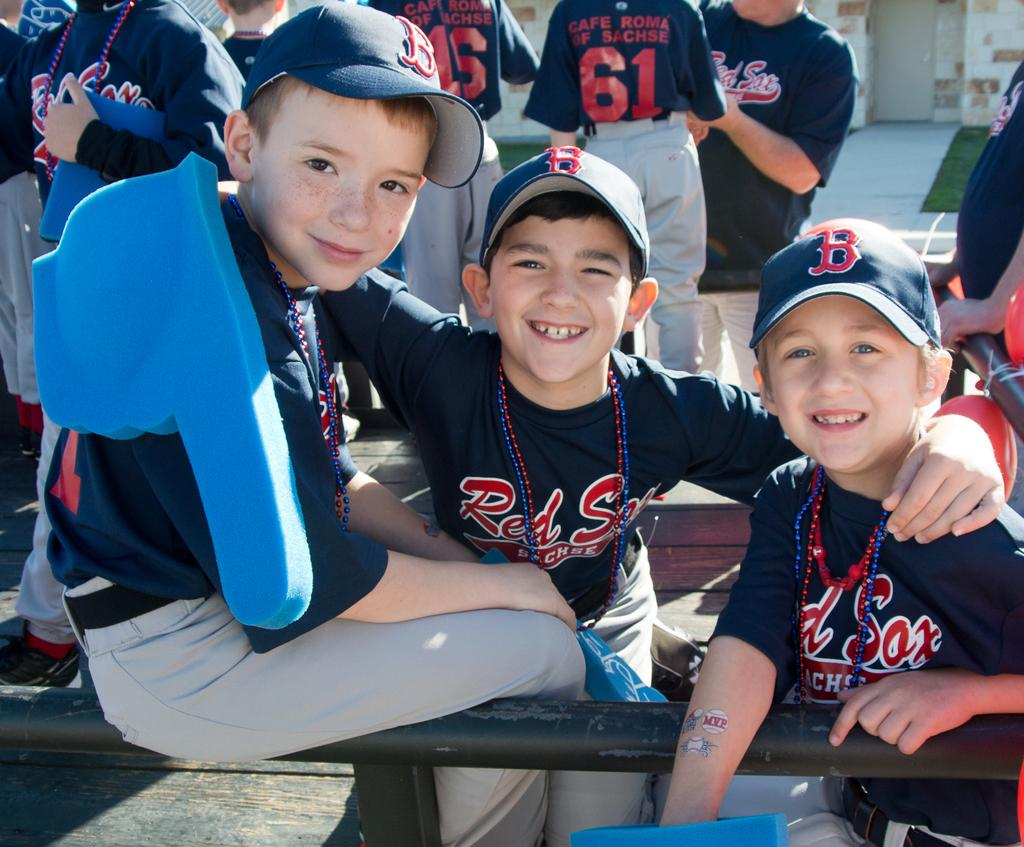Provide a one-sentence caption for the provided image. group of little league players wearing red sox uniforms sponsored by cafe roma of sachse. 